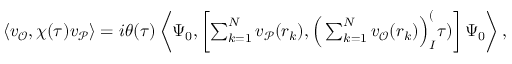<formula> <loc_0><loc_0><loc_500><loc_500>\begin{array} { r } { \langle v _ { \mathcal { O } } , \chi ( \tau ) v _ { \mathcal { P } } \rangle = i \theta ( \tau ) \left \langle \Psi _ { 0 } , \left [ \sum _ { k = 1 } ^ { N } v _ { \mathcal { P } } ( r _ { k } ) , \left ( \sum _ { k = 1 } ^ { N } v _ { \mathcal { O } } ( r _ { k } ) \right ) _ { I } ^ { ( } \tau ) \right ] \Psi _ { 0 } \right \rangle , } \end{array}</formula> 